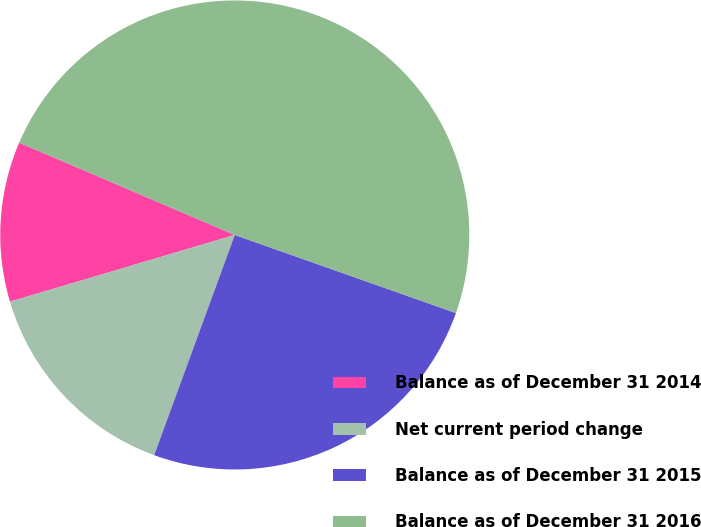Convert chart. <chart><loc_0><loc_0><loc_500><loc_500><pie_chart><fcel>Balance as of December 31 2014<fcel>Net current period change<fcel>Balance as of December 31 2015<fcel>Balance as of December 31 2016<nl><fcel>11.03%<fcel>14.82%<fcel>25.18%<fcel>48.96%<nl></chart> 